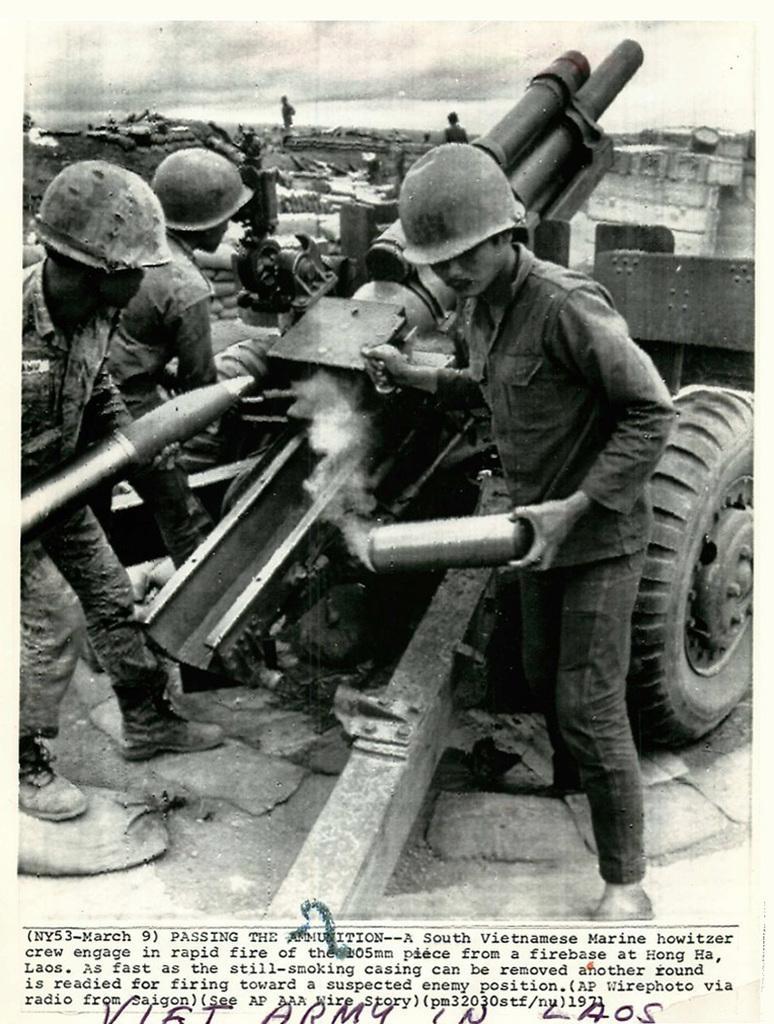In one or two sentences, can you explain what this image depicts? This is a poster. In this image we can see some persons, a vehicle and a text. 